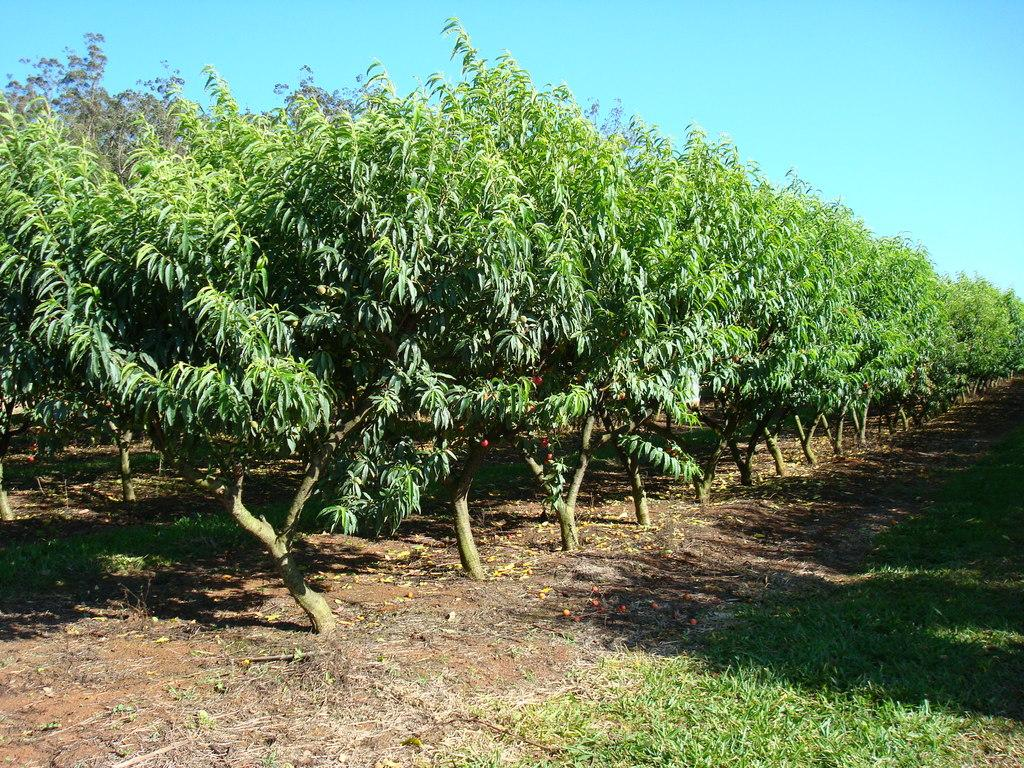What type of vegetation can be seen in the image? There are trees in the image. What is covering the ground in the image? There is grass on the surface in the image. What part of the natural environment is visible in the background of the image? The sky is visible in the background of the image. Can you hear the horse crying in the image? There is no horse or crying sound present in the image. 